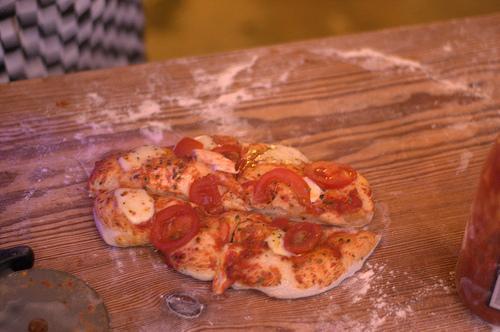How many tables are there?
Give a very brief answer. 1. 